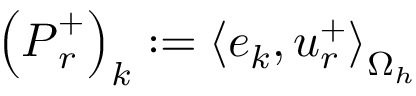Convert formula to latex. <formula><loc_0><loc_0><loc_500><loc_500>\left ( P _ { r } ^ { + } \right ) _ { k } \colon = \left < e _ { k } , u _ { r } ^ { + } \right > _ { \Omega _ { h } }</formula> 